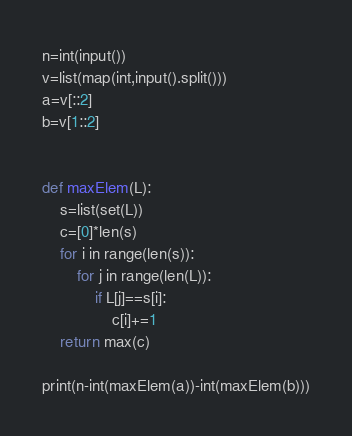<code> <loc_0><loc_0><loc_500><loc_500><_Python_>

n=int(input())
v=list(map(int,input().split()))
a=v[::2]
b=v[1::2]


def maxElem(L):
    s=list(set(L))
    c=[0]*len(s)
    for i in range(len(s)):
        for j in range(len(L)):
            if L[j]==s[i]:
                c[i]+=1
    return max(c)

print(n-int(maxElem(a))-int(maxElem(b)))</code> 